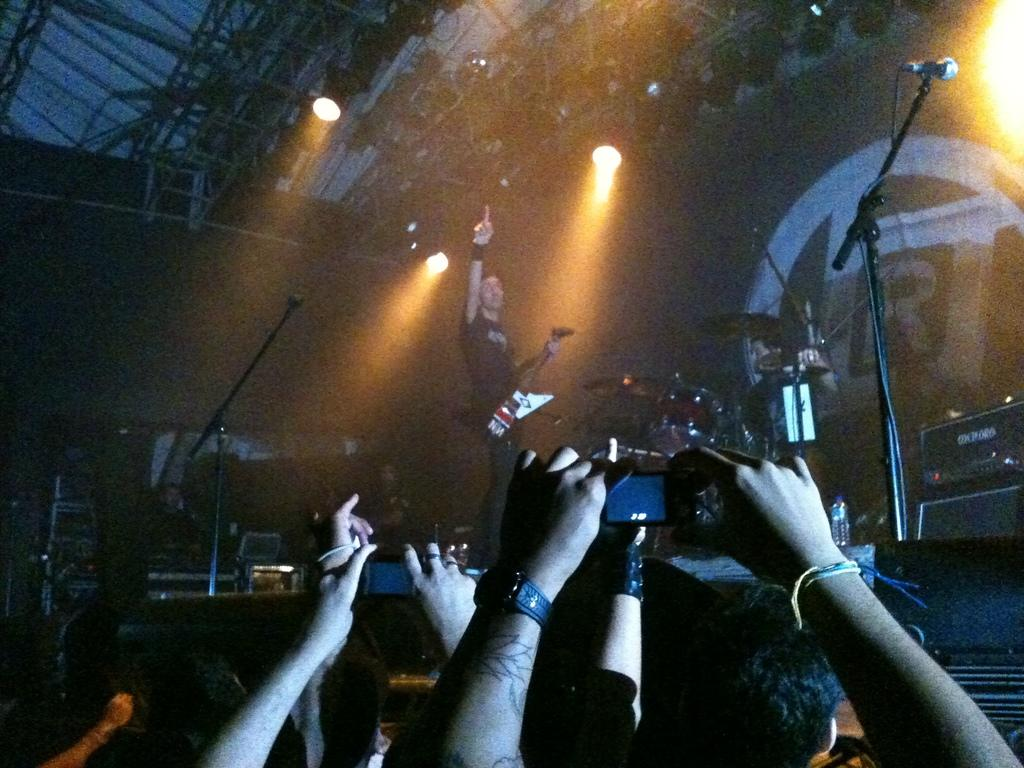Who or what can be seen in the image? There are people in the image. What objects are related to sound in the image? There are microphones in the image. What musical instruments are present in the image? There are musical drums in the image. What can be seen illuminating the scene in the image? There are lights in the image. What type of background is visible in the image? There is a wall in the image. How would you describe the lighting conditions in the image? The image is slightly dark. What type of cake is being served to the robin in the image? There is no cake or robin present in the image. How does the image stop the people from making noise? The image does not have the ability to stop people from making noise; it is a still image. 